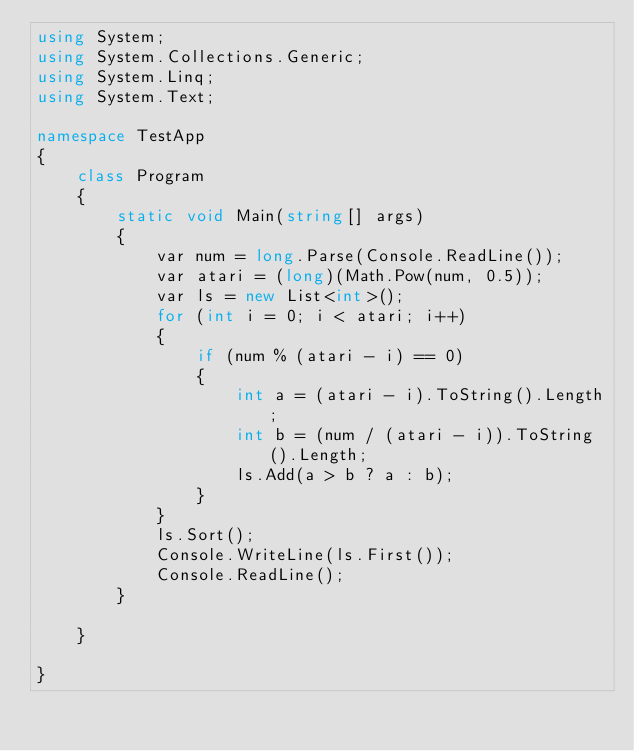<code> <loc_0><loc_0><loc_500><loc_500><_C#_>using System;
using System.Collections.Generic;
using System.Linq;
using System.Text;

namespace TestApp
{
    class Program
    {
        static void Main(string[] args)
        {
            var num = long.Parse(Console.ReadLine());
            var atari = (long)(Math.Pow(num, 0.5));
            var ls = new List<int>();
            for (int i = 0; i < atari; i++)
            {
                if (num % (atari - i) == 0)
                {
                    int a = (atari - i).ToString().Length;
                    int b = (num / (atari - i)).ToString().Length;
                    ls.Add(a > b ? a : b);
                }
            }
            ls.Sort();
            Console.WriteLine(ls.First());
            Console.ReadLine();
        }
        
    }

}</code> 